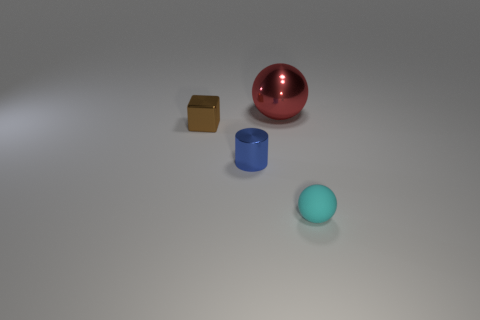Is there any other thing that is the same shape as the brown object?
Offer a very short reply. No. Is there any other thing that is the same size as the shiny sphere?
Give a very brief answer. No. What number of spheres are large cyan matte things or tiny cyan objects?
Provide a short and direct response. 1. Are there the same number of large shiny balls in front of the tiny brown metallic object and big purple shiny blocks?
Provide a succinct answer. Yes. What is the material of the sphere that is to the left of the object that is to the right of the sphere left of the cyan sphere?
Offer a terse response. Metal. How many things are either spheres behind the tiny cyan ball or blue metal cylinders?
Offer a terse response. 2. How many things are either tiny blocks or spheres that are in front of the large red thing?
Your answer should be compact. 2. What number of large metallic spheres are right of the ball in front of the shiny object that is on the right side of the blue metallic thing?
Provide a short and direct response. 0. What is the material of the blue thing that is the same size as the cyan rubber thing?
Your answer should be compact. Metal. Are there any cyan matte things that have the same size as the shiny block?
Your answer should be very brief. Yes. 